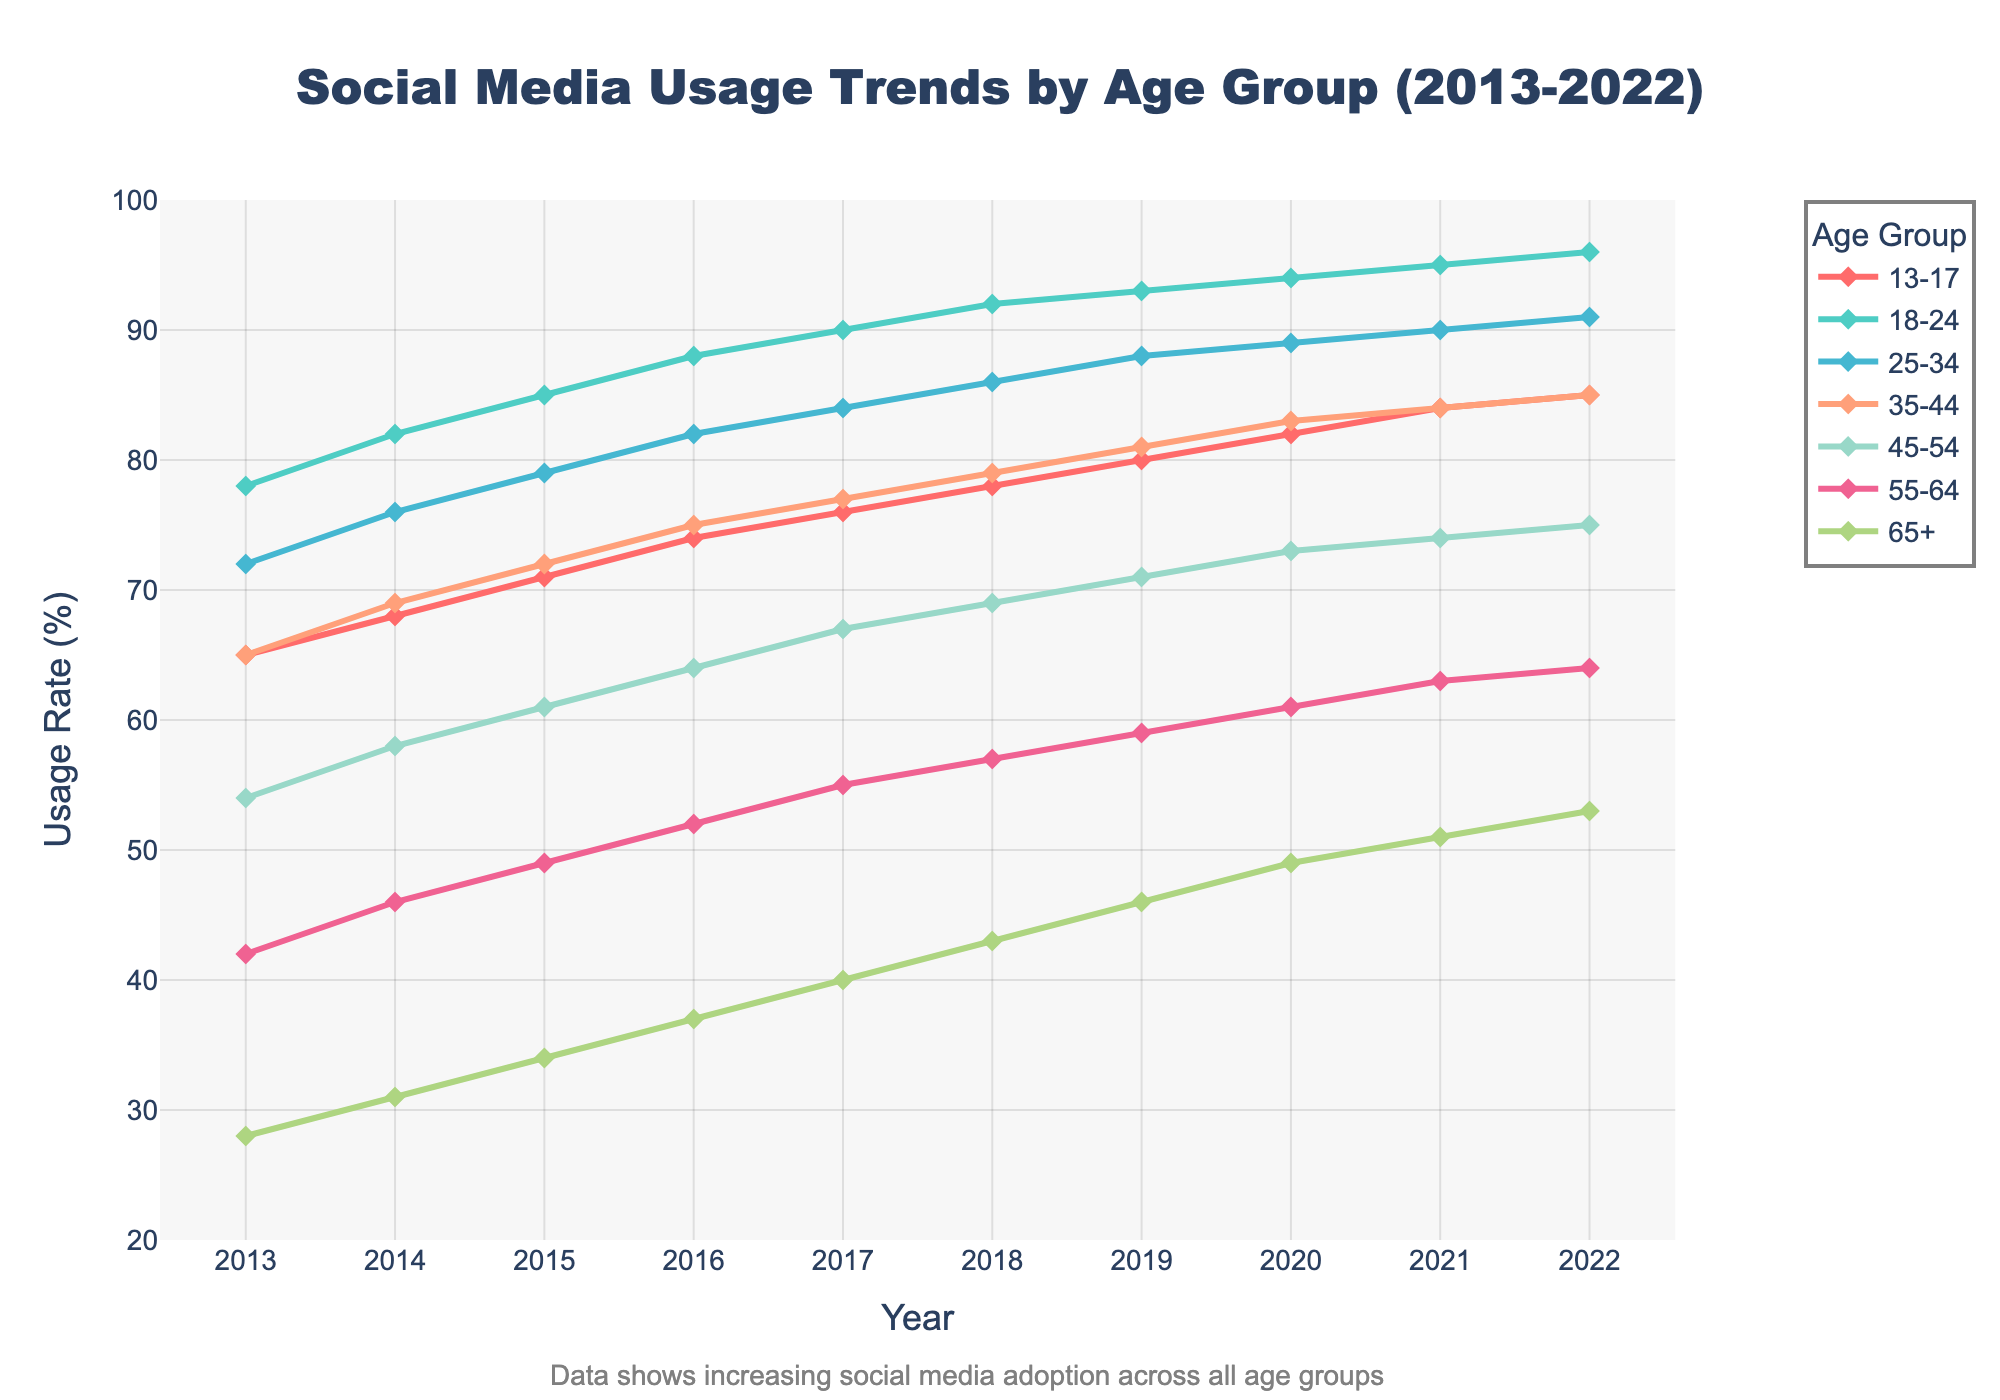Which age group showed the greatest increase in social media usage from 2013 to 2022? To find the age group with the greatest increase, subtract the 2013 usage rate from the 2022 rate for each age group.  For 13-17: 85-65=20, 18-24: 96-78=18, 25-34: 91-72=19, 35-44: 85-65=20, 45-54: 75-54=21, 55-64: 64-42=22, 65+: 53-28=25. The age group with the highest increase is 65+.
Answer: 65+ By how much did the social media usage rate increase for the 45-54 age group from 2013 to 2018? To determine the increase, subtract the 2013 rate from the 2018 rate for the 45-54 age group: 69 - 54 = 15. The social media usage rate increased by 15%.
Answer: 15% Which age group had the highest social media usage rate in 2016? Identify the rates for all age groups in 2016: 13-17: 74, 18-24: 88, 25-34: 82, 35-44: 75, 45-54: 64, 55-64: 52, 65+: 37. The highest rate is 88, which corresponds to the 18-24 age group.
Answer: 18-24 By what percentage did the social media usage rate for the 65+ age group increase from 2013 to 2022? Subtract the 2013 rate from the 2022 rate for the 65+ group and divide by the 2013 rate: (53 - 28) / 28 × 100%. This equals approximately 89.3%.
Answer: 89.3% Which age group had a greater increase in social media usage between 2014 and 2017, the 13-17 group or the 25-34 group? Calculate the increase for each group: 13-17: 76-68=8 and 25-34: 84-76=8. Both groups had an increase of 8%.
Answer: Both groups had equal increases Which age group showed relatively stable increase patterns across the decade? Assess the line slopes visually; the 35-44 age group's line consistently rises with a stable slope, indicating a steady, less variable increase.
Answer: 35-44 How did the social media usage rate for the 13-17 age group change from 2021 to 2022? Compare the usage rates: 2022 rate was 85 and 2021 rate was 84. The increase is 85 - 84 = 1. The usage rate increased by 1%.
Answer: 1% What is the average social media usage rate for the 55-64 age group over the decade? Sum the values from 2013-2022 and divide by the number of years: (42 + 46 + 49 + 52 + 55 + 57 + 59 + 61 + 63 + 64) / 10 = 54.8%. The average usage rate is 54.8%.
Answer: 54.8% What is the difference in the social media usage rate between the 35-44 and the 45-54 age groups in 2020? Subtract the 45-54 age group's rate from the 35-44 age group's rate for 2020: 83 - 73 = 10. The difference is 10%.
Answer: 10% Which age group had the slowest growth in social media usage from 2019 to 2020? Calculate the change for each age group from 2019 to 2020: 13-17: 82-80=2, 18-24: 94-93=1, 25-34: 89-88=1, 35-44: 83-81=2, 45-54: 73-71=2, 55-64: 61-59=2, 65+: 49-46=3. The smallest increase is 1%, which applies to the 18-24 and 25-34 groups.
Answer: 18-24, 25-34 